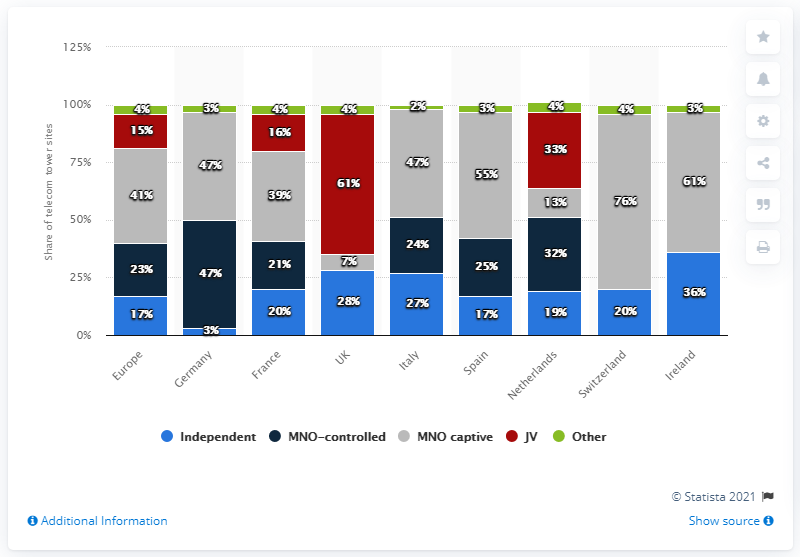Indicate a few pertinent items in this graphic. In the blue bar data, there are two countries whose data is divisible by 9, one of them is the United Kingdom and the other is Ireland. Identify the two letter country from the chart that is the United Kingdom. 